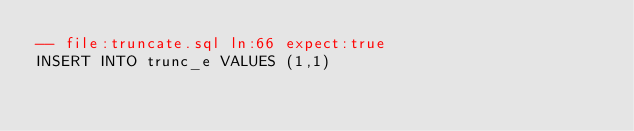Convert code to text. <code><loc_0><loc_0><loc_500><loc_500><_SQL_>-- file:truncate.sql ln:66 expect:true
INSERT INTO trunc_e VALUES (1,1)
</code> 